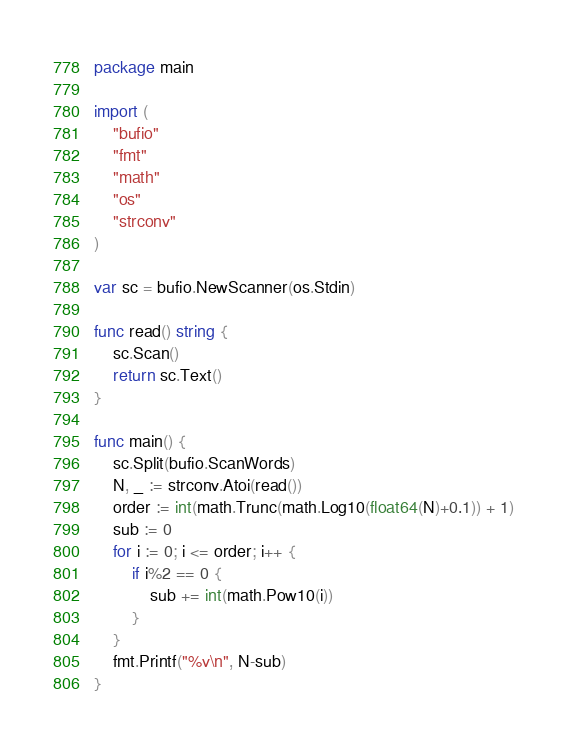<code> <loc_0><loc_0><loc_500><loc_500><_Go_>package main

import (
	"bufio"
	"fmt"
	"math"
	"os"
	"strconv"
)

var sc = bufio.NewScanner(os.Stdin)

func read() string {
	sc.Scan()
	return sc.Text()
}

func main() {
	sc.Split(bufio.ScanWords)
	N, _ := strconv.Atoi(read())
	order := int(math.Trunc(math.Log10(float64(N)+0.1)) + 1)
	sub := 0
	for i := 0; i <= order; i++ {
		if i%2 == 0 {
			sub += int(math.Pow10(i))
		}
	}
	fmt.Printf("%v\n", N-sub)
}
</code> 